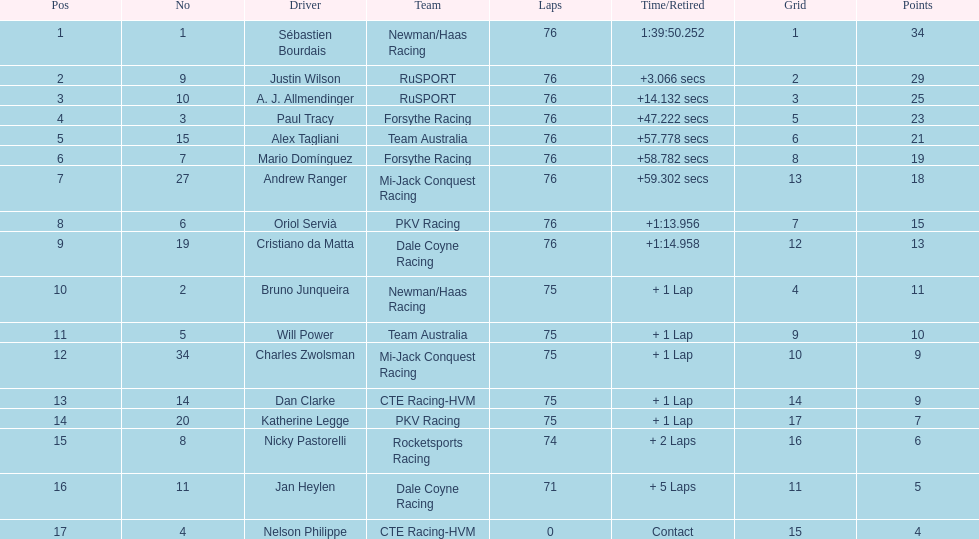What is the total point difference between the driver who received the most points and the driver who received the least? 30. 